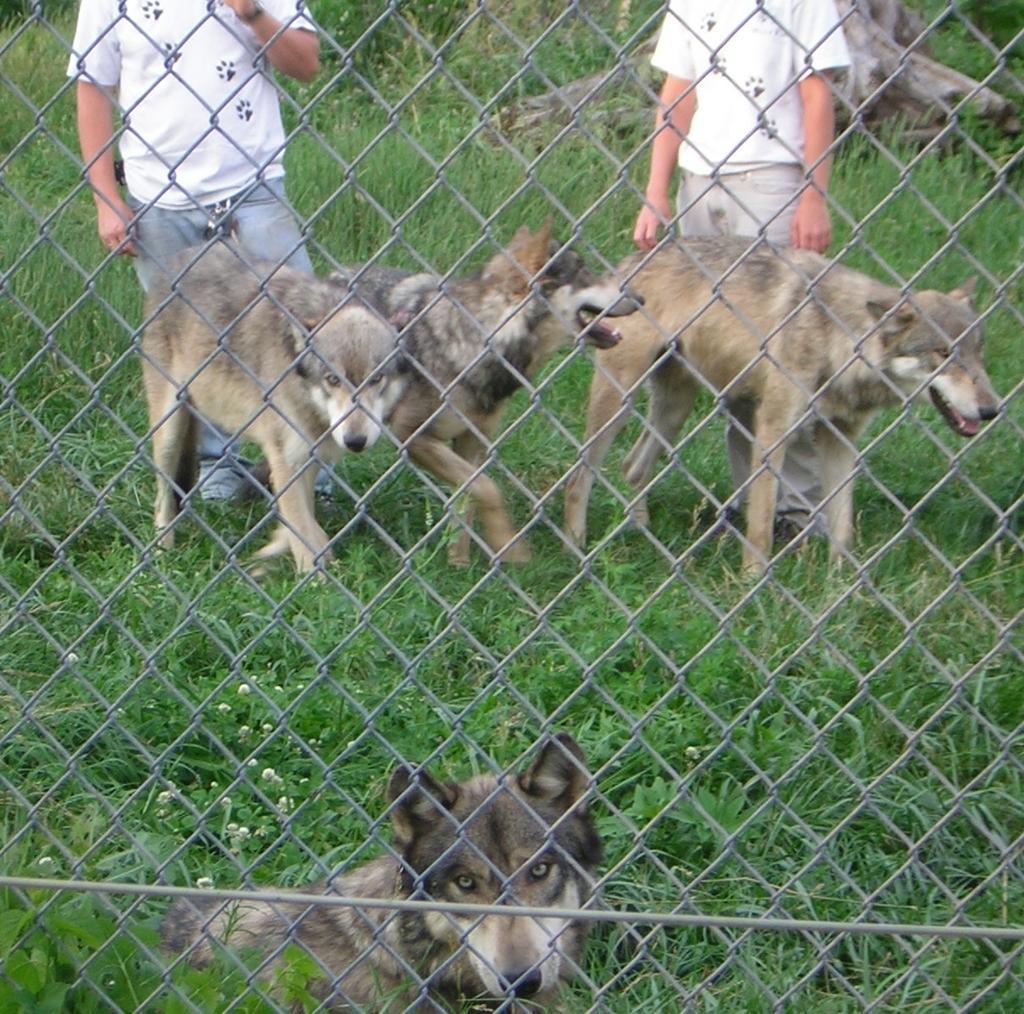In one or two sentences, can you explain what this image depicts? In front of the image there is a fencing. Behind the fencing there are three dogs standing and one dog is lying on the ground. On the ground there is grass. Behind the dogs there are two men standing. Behind the men there are wooden logs. 